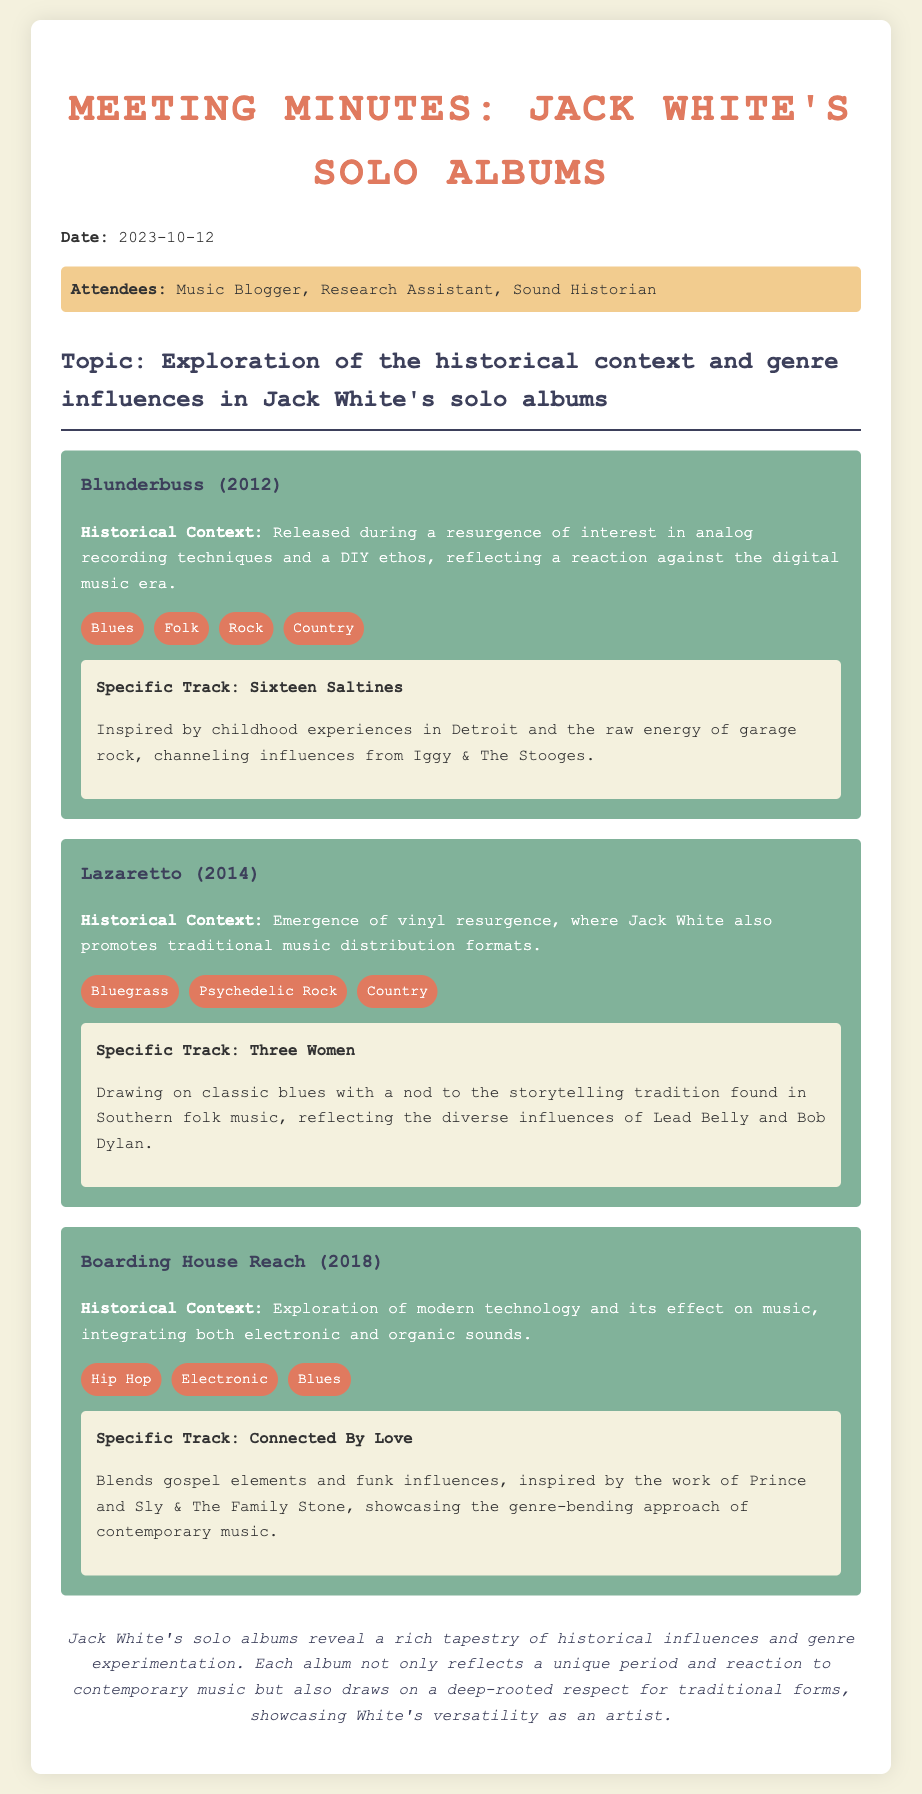What is the date of the meeting? The date of the meeting is clearly stated in the document's header.
Answer: 2023-10-12 Who are the attendees listed in the document? The attendees are provided in a highlighted section within the document.
Answer: Music Blogger, Research Assistant, Sound Historian What is the title of Jack White's first solo album discussed? The title of the first album is presented prominently under its own section in the meeting minutes.
Answer: Blunderbuss Which specific track from "Lazaretto" is mentioned in the document? The track is provided in a detailed breakdown of the album, showcasing its significance.
Answer: Three Women What genre influences are listed for "Boarding House Reach"? The genres are listed in a specific section dedicated to genre influences for that album.
Answer: Hip Hop, Electronic, Blues What is the main historical context for "Blunderbuss"? The historical context is described in the overview section related to the album.
Answer: Resurgence of interest in analog recording techniques Which artist is noted as an influence for the track "Connected By Love"? The influence is documented in the track's description, highlighting its genre-bending roots.
Answer: Prince How many albums are discussed in the meeting minutes? The count of albums is apparent from the sections dedicated to each album discussed.
Answer: Three What common theme is visible across Jack White's solo albums? The common theme is reflected in the conclusion of the document, summarizing the albums' characteristics.
Answer: Historical influences and genre experimentation 